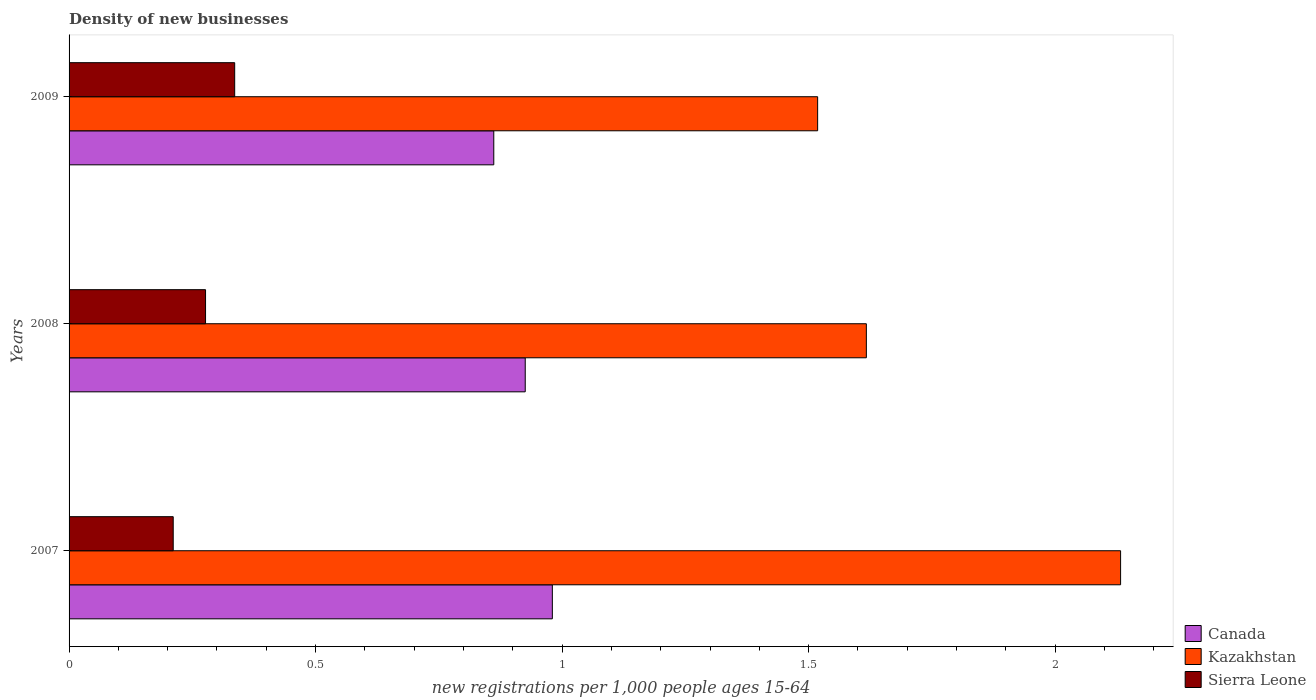How many different coloured bars are there?
Make the answer very short. 3. Are the number of bars per tick equal to the number of legend labels?
Ensure brevity in your answer.  Yes. How many bars are there on the 2nd tick from the top?
Offer a very short reply. 3. How many bars are there on the 3rd tick from the bottom?
Give a very brief answer. 3. In how many cases, is the number of bars for a given year not equal to the number of legend labels?
Offer a terse response. 0. What is the number of new registrations in Kazakhstan in 2007?
Offer a very short reply. 2.13. Across all years, what is the maximum number of new registrations in Kazakhstan?
Make the answer very short. 2.13. Across all years, what is the minimum number of new registrations in Sierra Leone?
Your answer should be very brief. 0.21. What is the total number of new registrations in Canada in the graph?
Provide a short and direct response. 2.77. What is the difference between the number of new registrations in Sierra Leone in 2007 and that in 2009?
Offer a terse response. -0.12. What is the difference between the number of new registrations in Kazakhstan in 2008 and the number of new registrations in Sierra Leone in 2007?
Offer a very short reply. 1.41. What is the average number of new registrations in Canada per year?
Give a very brief answer. 0.92. In the year 2007, what is the difference between the number of new registrations in Sierra Leone and number of new registrations in Canada?
Provide a succinct answer. -0.77. In how many years, is the number of new registrations in Sierra Leone greater than 1 ?
Offer a very short reply. 0. What is the ratio of the number of new registrations in Kazakhstan in 2008 to that in 2009?
Offer a very short reply. 1.07. Is the number of new registrations in Sierra Leone in 2007 less than that in 2008?
Offer a terse response. Yes. What is the difference between the highest and the second highest number of new registrations in Canada?
Your answer should be compact. 0.06. What is the difference between the highest and the lowest number of new registrations in Kazakhstan?
Your answer should be very brief. 0.61. What does the 1st bar from the top in 2009 represents?
Make the answer very short. Sierra Leone. What does the 2nd bar from the bottom in 2009 represents?
Your answer should be very brief. Kazakhstan. Is it the case that in every year, the sum of the number of new registrations in Sierra Leone and number of new registrations in Kazakhstan is greater than the number of new registrations in Canada?
Offer a very short reply. Yes. How many bars are there?
Provide a succinct answer. 9. Are the values on the major ticks of X-axis written in scientific E-notation?
Ensure brevity in your answer.  No. Does the graph contain any zero values?
Your answer should be compact. No. Where does the legend appear in the graph?
Your answer should be very brief. Bottom right. How are the legend labels stacked?
Your answer should be compact. Vertical. What is the title of the graph?
Ensure brevity in your answer.  Density of new businesses. What is the label or title of the X-axis?
Your answer should be compact. New registrations per 1,0 people ages 15-64. What is the new registrations per 1,000 people ages 15-64 of Canada in 2007?
Make the answer very short. 0.98. What is the new registrations per 1,000 people ages 15-64 in Kazakhstan in 2007?
Ensure brevity in your answer.  2.13. What is the new registrations per 1,000 people ages 15-64 of Sierra Leone in 2007?
Your answer should be compact. 0.21. What is the new registrations per 1,000 people ages 15-64 of Canada in 2008?
Provide a succinct answer. 0.93. What is the new registrations per 1,000 people ages 15-64 of Kazakhstan in 2008?
Ensure brevity in your answer.  1.62. What is the new registrations per 1,000 people ages 15-64 in Sierra Leone in 2008?
Offer a very short reply. 0.28. What is the new registrations per 1,000 people ages 15-64 of Canada in 2009?
Keep it short and to the point. 0.86. What is the new registrations per 1,000 people ages 15-64 of Kazakhstan in 2009?
Provide a short and direct response. 1.52. What is the new registrations per 1,000 people ages 15-64 in Sierra Leone in 2009?
Offer a very short reply. 0.34. Across all years, what is the maximum new registrations per 1,000 people ages 15-64 in Canada?
Your response must be concise. 0.98. Across all years, what is the maximum new registrations per 1,000 people ages 15-64 in Kazakhstan?
Make the answer very short. 2.13. Across all years, what is the maximum new registrations per 1,000 people ages 15-64 of Sierra Leone?
Provide a short and direct response. 0.34. Across all years, what is the minimum new registrations per 1,000 people ages 15-64 in Canada?
Your answer should be very brief. 0.86. Across all years, what is the minimum new registrations per 1,000 people ages 15-64 of Kazakhstan?
Your response must be concise. 1.52. Across all years, what is the minimum new registrations per 1,000 people ages 15-64 of Sierra Leone?
Keep it short and to the point. 0.21. What is the total new registrations per 1,000 people ages 15-64 of Canada in the graph?
Provide a succinct answer. 2.77. What is the total new registrations per 1,000 people ages 15-64 in Kazakhstan in the graph?
Keep it short and to the point. 5.27. What is the total new registrations per 1,000 people ages 15-64 in Sierra Leone in the graph?
Give a very brief answer. 0.82. What is the difference between the new registrations per 1,000 people ages 15-64 in Canada in 2007 and that in 2008?
Give a very brief answer. 0.06. What is the difference between the new registrations per 1,000 people ages 15-64 of Kazakhstan in 2007 and that in 2008?
Your answer should be very brief. 0.52. What is the difference between the new registrations per 1,000 people ages 15-64 in Sierra Leone in 2007 and that in 2008?
Make the answer very short. -0.07. What is the difference between the new registrations per 1,000 people ages 15-64 of Canada in 2007 and that in 2009?
Provide a short and direct response. 0.12. What is the difference between the new registrations per 1,000 people ages 15-64 in Kazakhstan in 2007 and that in 2009?
Provide a succinct answer. 0.61. What is the difference between the new registrations per 1,000 people ages 15-64 in Sierra Leone in 2007 and that in 2009?
Your answer should be compact. -0.12. What is the difference between the new registrations per 1,000 people ages 15-64 of Canada in 2008 and that in 2009?
Keep it short and to the point. 0.06. What is the difference between the new registrations per 1,000 people ages 15-64 in Kazakhstan in 2008 and that in 2009?
Offer a very short reply. 0.1. What is the difference between the new registrations per 1,000 people ages 15-64 of Sierra Leone in 2008 and that in 2009?
Your response must be concise. -0.06. What is the difference between the new registrations per 1,000 people ages 15-64 of Canada in 2007 and the new registrations per 1,000 people ages 15-64 of Kazakhstan in 2008?
Your answer should be very brief. -0.64. What is the difference between the new registrations per 1,000 people ages 15-64 in Canada in 2007 and the new registrations per 1,000 people ages 15-64 in Sierra Leone in 2008?
Keep it short and to the point. 0.7. What is the difference between the new registrations per 1,000 people ages 15-64 in Kazakhstan in 2007 and the new registrations per 1,000 people ages 15-64 in Sierra Leone in 2008?
Ensure brevity in your answer.  1.86. What is the difference between the new registrations per 1,000 people ages 15-64 of Canada in 2007 and the new registrations per 1,000 people ages 15-64 of Kazakhstan in 2009?
Your answer should be compact. -0.54. What is the difference between the new registrations per 1,000 people ages 15-64 in Canada in 2007 and the new registrations per 1,000 people ages 15-64 in Sierra Leone in 2009?
Your answer should be very brief. 0.64. What is the difference between the new registrations per 1,000 people ages 15-64 in Kazakhstan in 2007 and the new registrations per 1,000 people ages 15-64 in Sierra Leone in 2009?
Your answer should be very brief. 1.8. What is the difference between the new registrations per 1,000 people ages 15-64 in Canada in 2008 and the new registrations per 1,000 people ages 15-64 in Kazakhstan in 2009?
Provide a short and direct response. -0.59. What is the difference between the new registrations per 1,000 people ages 15-64 of Canada in 2008 and the new registrations per 1,000 people ages 15-64 of Sierra Leone in 2009?
Ensure brevity in your answer.  0.59. What is the difference between the new registrations per 1,000 people ages 15-64 in Kazakhstan in 2008 and the new registrations per 1,000 people ages 15-64 in Sierra Leone in 2009?
Ensure brevity in your answer.  1.28. What is the average new registrations per 1,000 people ages 15-64 of Canada per year?
Your answer should be compact. 0.92. What is the average new registrations per 1,000 people ages 15-64 of Kazakhstan per year?
Make the answer very short. 1.76. What is the average new registrations per 1,000 people ages 15-64 of Sierra Leone per year?
Your answer should be very brief. 0.27. In the year 2007, what is the difference between the new registrations per 1,000 people ages 15-64 in Canada and new registrations per 1,000 people ages 15-64 in Kazakhstan?
Ensure brevity in your answer.  -1.15. In the year 2007, what is the difference between the new registrations per 1,000 people ages 15-64 in Canada and new registrations per 1,000 people ages 15-64 in Sierra Leone?
Provide a short and direct response. 0.77. In the year 2007, what is the difference between the new registrations per 1,000 people ages 15-64 of Kazakhstan and new registrations per 1,000 people ages 15-64 of Sierra Leone?
Make the answer very short. 1.92. In the year 2008, what is the difference between the new registrations per 1,000 people ages 15-64 of Canada and new registrations per 1,000 people ages 15-64 of Kazakhstan?
Make the answer very short. -0.69. In the year 2008, what is the difference between the new registrations per 1,000 people ages 15-64 of Canada and new registrations per 1,000 people ages 15-64 of Sierra Leone?
Give a very brief answer. 0.65. In the year 2008, what is the difference between the new registrations per 1,000 people ages 15-64 of Kazakhstan and new registrations per 1,000 people ages 15-64 of Sierra Leone?
Provide a succinct answer. 1.34. In the year 2009, what is the difference between the new registrations per 1,000 people ages 15-64 of Canada and new registrations per 1,000 people ages 15-64 of Kazakhstan?
Provide a succinct answer. -0.66. In the year 2009, what is the difference between the new registrations per 1,000 people ages 15-64 in Canada and new registrations per 1,000 people ages 15-64 in Sierra Leone?
Give a very brief answer. 0.53. In the year 2009, what is the difference between the new registrations per 1,000 people ages 15-64 in Kazakhstan and new registrations per 1,000 people ages 15-64 in Sierra Leone?
Make the answer very short. 1.18. What is the ratio of the new registrations per 1,000 people ages 15-64 in Canada in 2007 to that in 2008?
Your response must be concise. 1.06. What is the ratio of the new registrations per 1,000 people ages 15-64 of Kazakhstan in 2007 to that in 2008?
Your answer should be compact. 1.32. What is the ratio of the new registrations per 1,000 people ages 15-64 of Sierra Leone in 2007 to that in 2008?
Make the answer very short. 0.76. What is the ratio of the new registrations per 1,000 people ages 15-64 of Canada in 2007 to that in 2009?
Keep it short and to the point. 1.14. What is the ratio of the new registrations per 1,000 people ages 15-64 of Kazakhstan in 2007 to that in 2009?
Your response must be concise. 1.4. What is the ratio of the new registrations per 1,000 people ages 15-64 of Sierra Leone in 2007 to that in 2009?
Provide a succinct answer. 0.63. What is the ratio of the new registrations per 1,000 people ages 15-64 of Canada in 2008 to that in 2009?
Provide a succinct answer. 1.07. What is the ratio of the new registrations per 1,000 people ages 15-64 in Kazakhstan in 2008 to that in 2009?
Give a very brief answer. 1.07. What is the ratio of the new registrations per 1,000 people ages 15-64 in Sierra Leone in 2008 to that in 2009?
Your answer should be very brief. 0.82. What is the difference between the highest and the second highest new registrations per 1,000 people ages 15-64 of Canada?
Give a very brief answer. 0.06. What is the difference between the highest and the second highest new registrations per 1,000 people ages 15-64 of Kazakhstan?
Your answer should be compact. 0.52. What is the difference between the highest and the second highest new registrations per 1,000 people ages 15-64 in Sierra Leone?
Your response must be concise. 0.06. What is the difference between the highest and the lowest new registrations per 1,000 people ages 15-64 of Canada?
Make the answer very short. 0.12. What is the difference between the highest and the lowest new registrations per 1,000 people ages 15-64 of Kazakhstan?
Keep it short and to the point. 0.61. What is the difference between the highest and the lowest new registrations per 1,000 people ages 15-64 in Sierra Leone?
Ensure brevity in your answer.  0.12. 